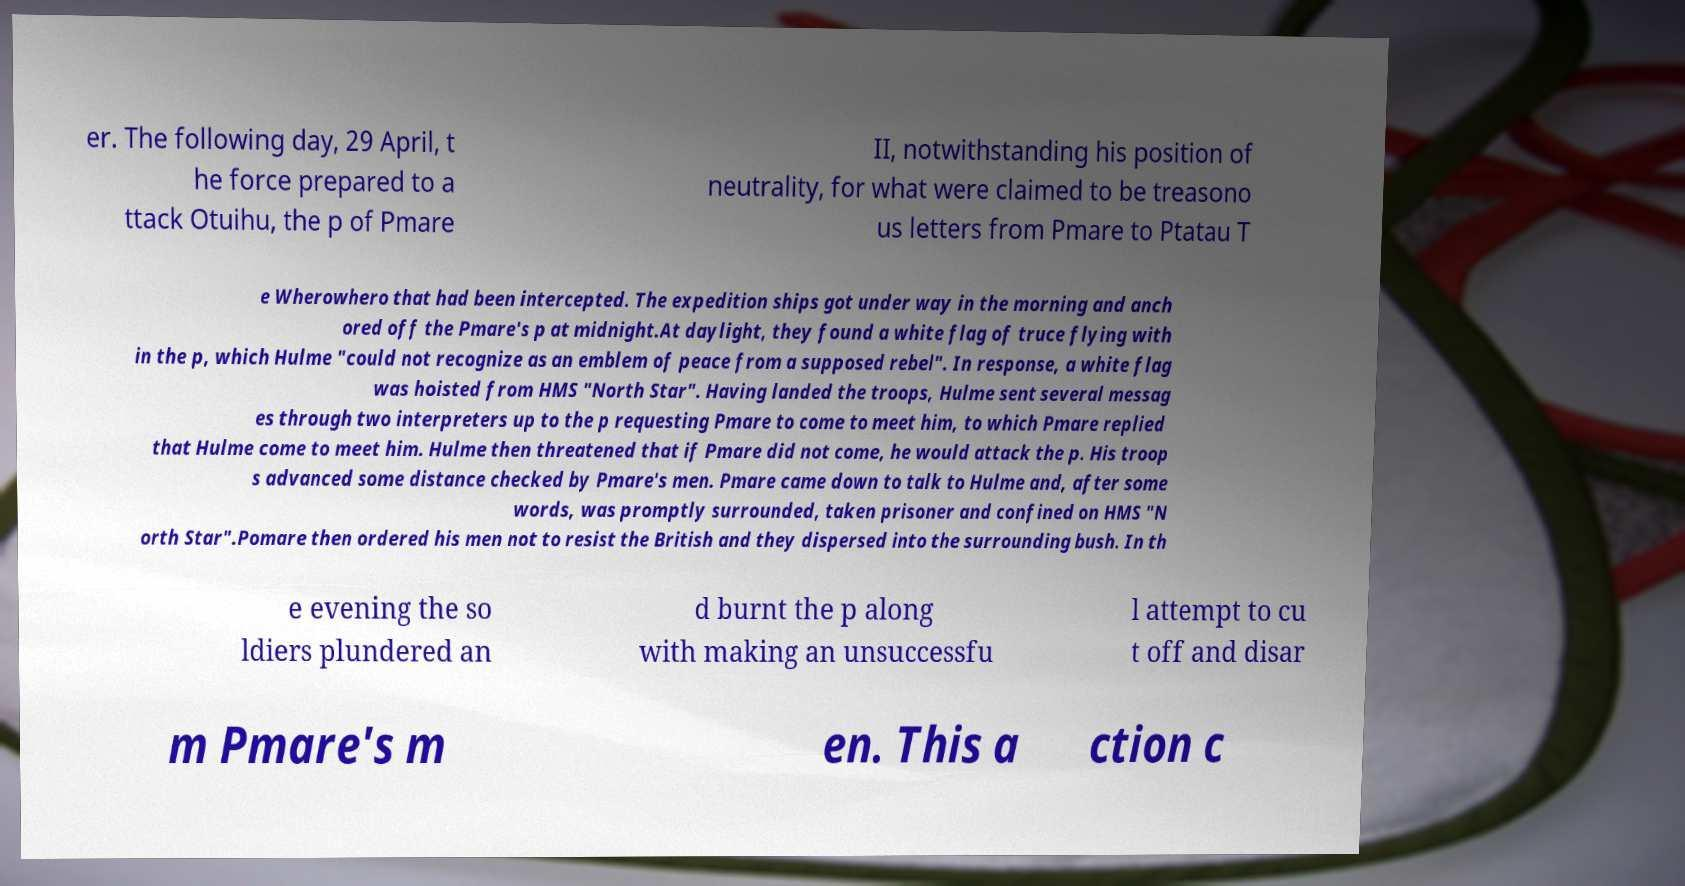I need the written content from this picture converted into text. Can you do that? er. The following day, 29 April, t he force prepared to a ttack Otuihu, the p of Pmare II, notwithstanding his position of neutrality, for what were claimed to be treasono us letters from Pmare to Ptatau T e Wherowhero that had been intercepted. The expedition ships got under way in the morning and anch ored off the Pmare's p at midnight.At daylight, they found a white flag of truce flying with in the p, which Hulme "could not recognize as an emblem of peace from a supposed rebel". In response, a white flag was hoisted from HMS "North Star". Having landed the troops, Hulme sent several messag es through two interpreters up to the p requesting Pmare to come to meet him, to which Pmare replied that Hulme come to meet him. Hulme then threatened that if Pmare did not come, he would attack the p. His troop s advanced some distance checked by Pmare's men. Pmare came down to talk to Hulme and, after some words, was promptly surrounded, taken prisoner and confined on HMS "N orth Star".Pomare then ordered his men not to resist the British and they dispersed into the surrounding bush. In th e evening the so ldiers plundered an d burnt the p along with making an unsuccessfu l attempt to cu t off and disar m Pmare's m en. This a ction c 